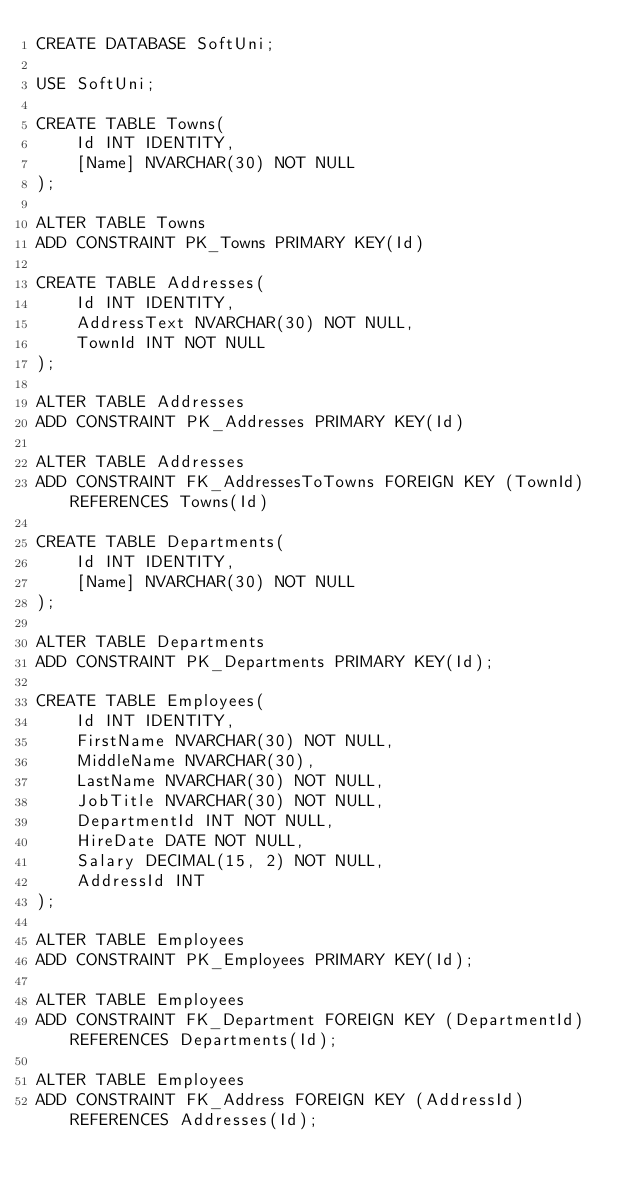Convert code to text. <code><loc_0><loc_0><loc_500><loc_500><_SQL_>CREATE DATABASE SoftUni;

USE SoftUni;

CREATE TABLE Towns(
	Id INT IDENTITY,
	[Name] NVARCHAR(30) NOT NULL
);

ALTER TABLE Towns
ADD CONSTRAINT PK_Towns PRIMARY KEY(Id)

CREATE TABLE Addresses(
	Id INT IDENTITY,
	AddressText NVARCHAR(30) NOT NULL,
	TownId INT NOT NULL
);

ALTER TABLE Addresses
ADD CONSTRAINT PK_Addresses PRIMARY KEY(Id)

ALTER TABLE Addresses
ADD CONSTRAINT FK_AddressesToTowns FOREIGN KEY (TownId) REFERENCES Towns(Id)

CREATE TABLE Departments(
	Id INT IDENTITY,
	[Name] NVARCHAR(30) NOT NULL
);

ALTER TABLE Departments
ADD CONSTRAINT PK_Departments PRIMARY KEY(Id);

CREATE TABLE Employees(
	Id INT IDENTITY,
	FirstName NVARCHAR(30) NOT NULL,
	MiddleName NVARCHAR(30),
	LastName NVARCHAR(30) NOT NULL,
	JobTitle NVARCHAR(30) NOT NULL,
	DepartmentId INT NOT NULL,
	HireDate DATE NOT NULL,
	Salary DECIMAL(15, 2) NOT NULL,
	AddressId INT
);

ALTER TABLE Employees
ADD CONSTRAINT PK_Employees PRIMARY KEY(Id);

ALTER TABLE Employees
ADD CONSTRAINT FK_Department FOREIGN KEY (DepartmentId) REFERENCES Departments(Id);

ALTER TABLE Employees
ADD CONSTRAINT FK_Address FOREIGN KEY (AddressId) REFERENCES Addresses(Id);</code> 